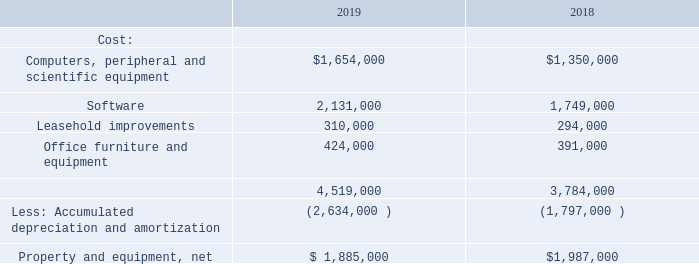NOTE 5—PROPERTY AND EQUIPMENT, NET
Property and equipment, net, consists of the following as of December 31, 2019 and 2018:
Depreciation for the years ended December 31, 2019 and December 31, 2018 was $870,000 and $704,000, respectively. Cost basis of assets disposed for the years ended December 31, 2019 and December 31, 2018 was $31,000 and $773,000, respectively. The disposals in 2018 were primarily a result of relocating our corporate offices and writing off the fully amortized leasehold improvements related to our former office.
What are the components recorded under cost? Computers, peripheral and scientific equipment, software, leasehold improvements, office furniture and equipment. What was the cost of disposals in 2019? $31,000. What was the reason for the disposals in 2018? Relocating our corporate offices and writing off the fully amortized leasehold improvements related to our former office. Which year has a higher depreciation? $870,000 > $704,000
Answer: 2019. What was the change in software cost from 2018 to 2019? 2,131,000 - 1,749,000 
Answer: 382000. What was the percentage change in the net property and equipment?
Answer scale should be: percent. ($1,885,000 - $1,987,000)/$1,987,000 
Answer: -5.13. 